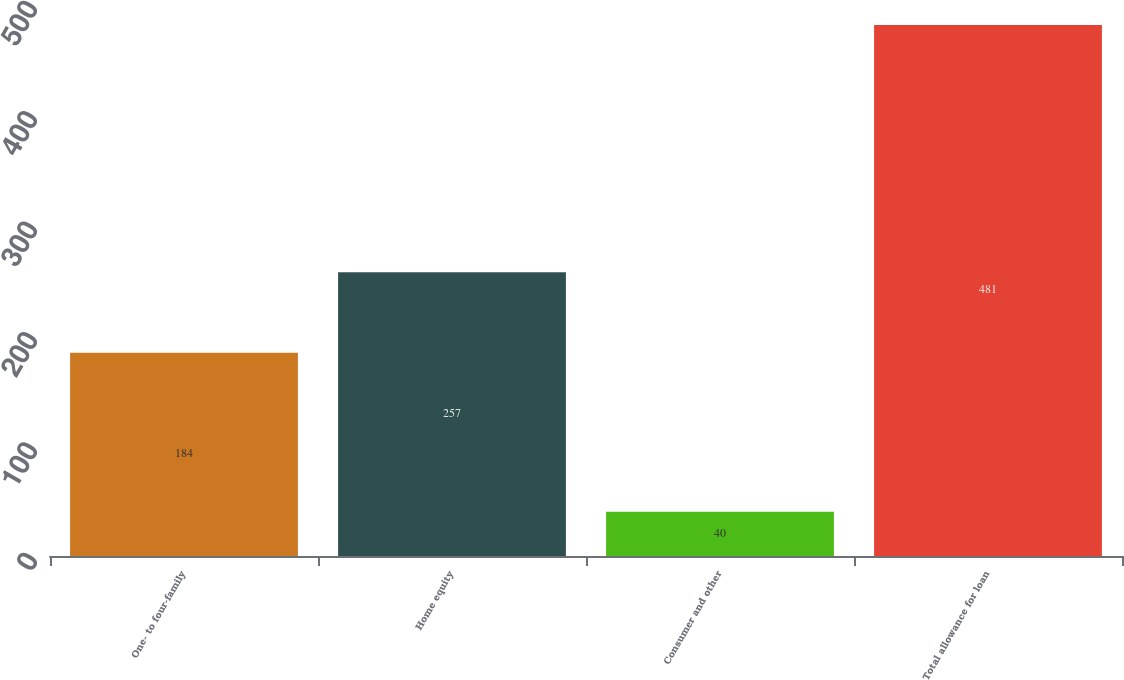<chart> <loc_0><loc_0><loc_500><loc_500><bar_chart><fcel>One- to four-family<fcel>Home equity<fcel>Consumer and other<fcel>Total allowance for loan<nl><fcel>184<fcel>257<fcel>40<fcel>481<nl></chart> 